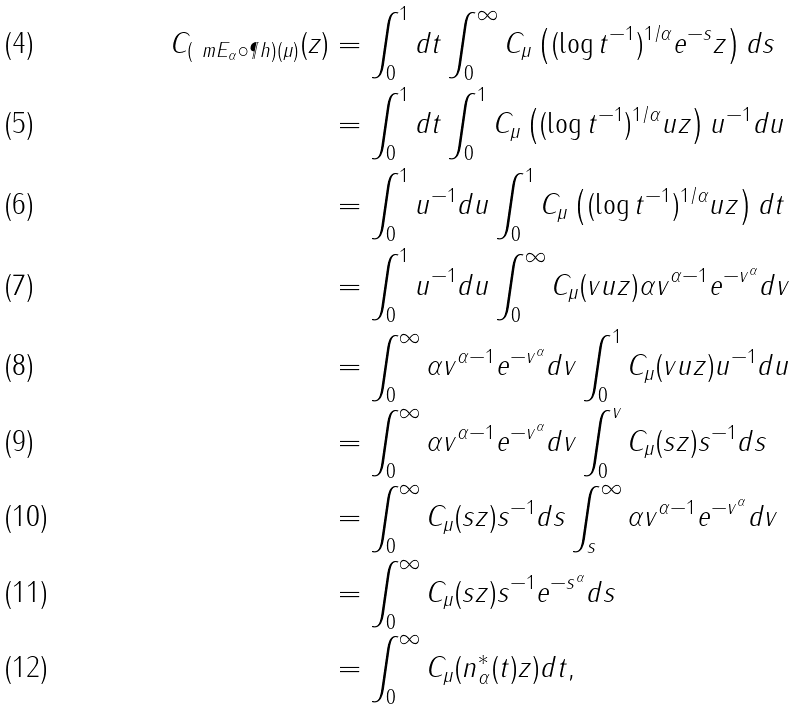<formula> <loc_0><loc_0><loc_500><loc_500>C _ { ( \ m E _ { \alpha } \circ \P h ) ( \mu ) } ( z ) & = \int _ { 0 } ^ { 1 } d t \int _ { 0 } ^ { \infty } C _ { \mu } \left ( ( \log t ^ { - 1 } ) ^ { 1 / \alpha } e ^ { - s } z \right ) d s \\ & = \int _ { 0 } ^ { 1 } d t \int _ { 0 } ^ { 1 } C _ { \mu } \left ( ( \log t ^ { - 1 } ) ^ { 1 / \alpha } u z \right ) u ^ { - 1 } d u \\ & = \int _ { 0 } ^ { 1 } u ^ { - 1 } d u \int _ { 0 } ^ { 1 } C _ { \mu } \left ( ( \log t ^ { - 1 } ) ^ { 1 / \alpha } u z \right ) d t \\ & = \int _ { 0 } ^ { 1 } u ^ { - 1 } d u \int _ { 0 } ^ { \infty } C _ { \mu } ( v u z ) \alpha v ^ { \alpha - 1 } e ^ { - v ^ { \alpha } } d v \\ & = \int _ { 0 } ^ { \infty } \alpha v ^ { \alpha - 1 } e ^ { - v ^ { \alpha } } d v \int _ { 0 } ^ { 1 } C _ { \mu } ( v u z ) u ^ { - 1 } d u \\ & = \int _ { 0 } ^ { \infty } \alpha v ^ { \alpha - 1 } e ^ { - v ^ { \alpha } } d v \int _ { 0 } ^ { v } C _ { \mu } ( s z ) s ^ { - 1 } d s \\ & = \int _ { 0 } ^ { \infty } C _ { \mu } ( s z ) s ^ { - 1 } d s \int _ { s } ^ { \infty } \alpha v ^ { \alpha - 1 } e ^ { - v ^ { \alpha } } d v \\ & = \int _ { 0 } ^ { \infty } C _ { \mu } ( s z ) s ^ { - 1 } e ^ { - s ^ { \alpha } } d s \\ & = \int _ { 0 } ^ { \infty } C _ { \mu } ( n _ { \alpha } ^ { \ast } ( t ) z ) d t ,</formula> 